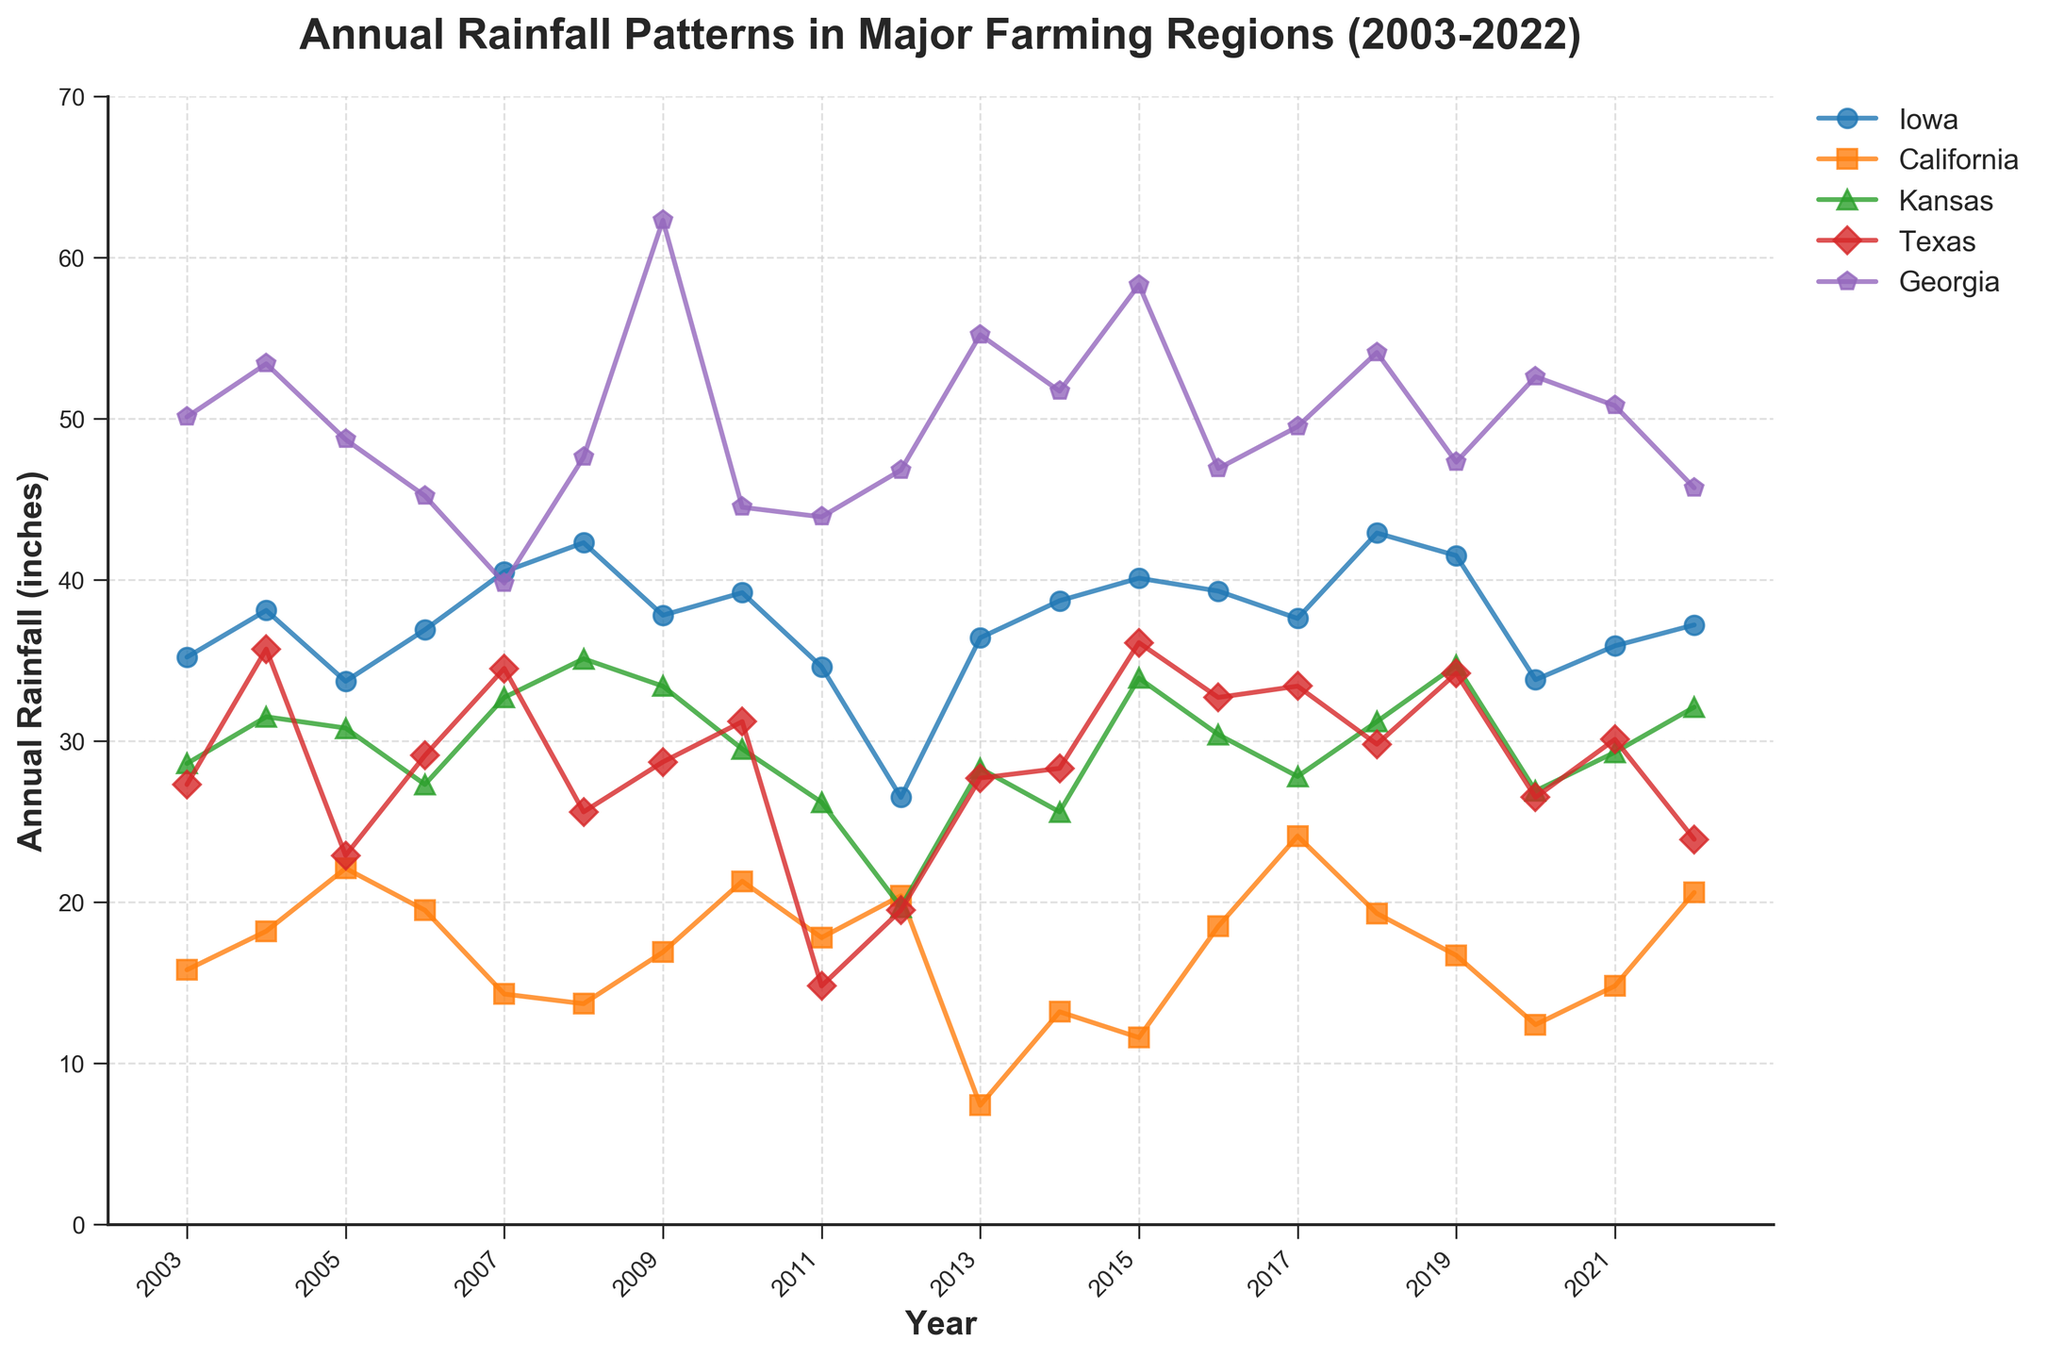What year did Georgia receive the highest annual rainfall? Find the highest point on the line corresponding to Georgia and check the year label. The peak is at 62.3 inches in 2009.
Answer: 2009 Which state generally has the lowest annual rainfall? From visual inspection, California consistently has the lowest line on the chart among the five states.
Answer: California Was there a year when Texas had higher rainfall than Iowa? Compare the lines for Texas and Iowa year by year. In 2004, Texas (35.7) had more rainfall than Iowa (38.1).
Answer: 2004 What is the average annual rainfall for Kansas from 2003 to 2022? Sum the values for Kansas and divide by the number of years (20). The average is (634.2 inches divided by 20 years).
Answer: 31.71 inches Which year had the most variability in rainfall among the five states? Find the year with the largest visual spread between the highest and lowest points. In 2013, the range (Georgia 55.2, California 7.4) shows the highest variability.
Answer: 2013 What are the 3 highest annual rainfall years for Iowa? Identify the three highest points on Iowa's line and check the corresponding years. The highest values occur in 2018 (42.9), 2008 (42.3), and 2007 (40.5).
Answer: 2018, 2008, 2007 How much more rainfall did Georgia receive in 2011 compared to Texas in the same year? Subtract Texas's rainfall from Georgia's rainfall for 2011 (43.9 - 14.8).
Answer: 29.1 inches Does 2012 have the lowest rainfall for any state? Compare the rainfall values for 2012 against other years for each state. Kansas has its lowest rainfall in 2012 with 19.7 inches.
Answer: Yes, in Kansas Which state's rainfall trend appears most stable between 2003 and 2022? A stable trend would show minimal fluctuations. Visually, Iowa has a relatively stable trend with fewer drastic changes.
Answer: Iowa Did any state reach more than 50 inches of rainfall besides Georgia? Check all lines for rainfall values above 50 inches. Only Georgia surpasses 50 inches multiple times.
Answer: No 